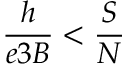<formula> <loc_0><loc_0><loc_500><loc_500>\frac { h } { e 3 B } < \frac { S } { N }</formula> 